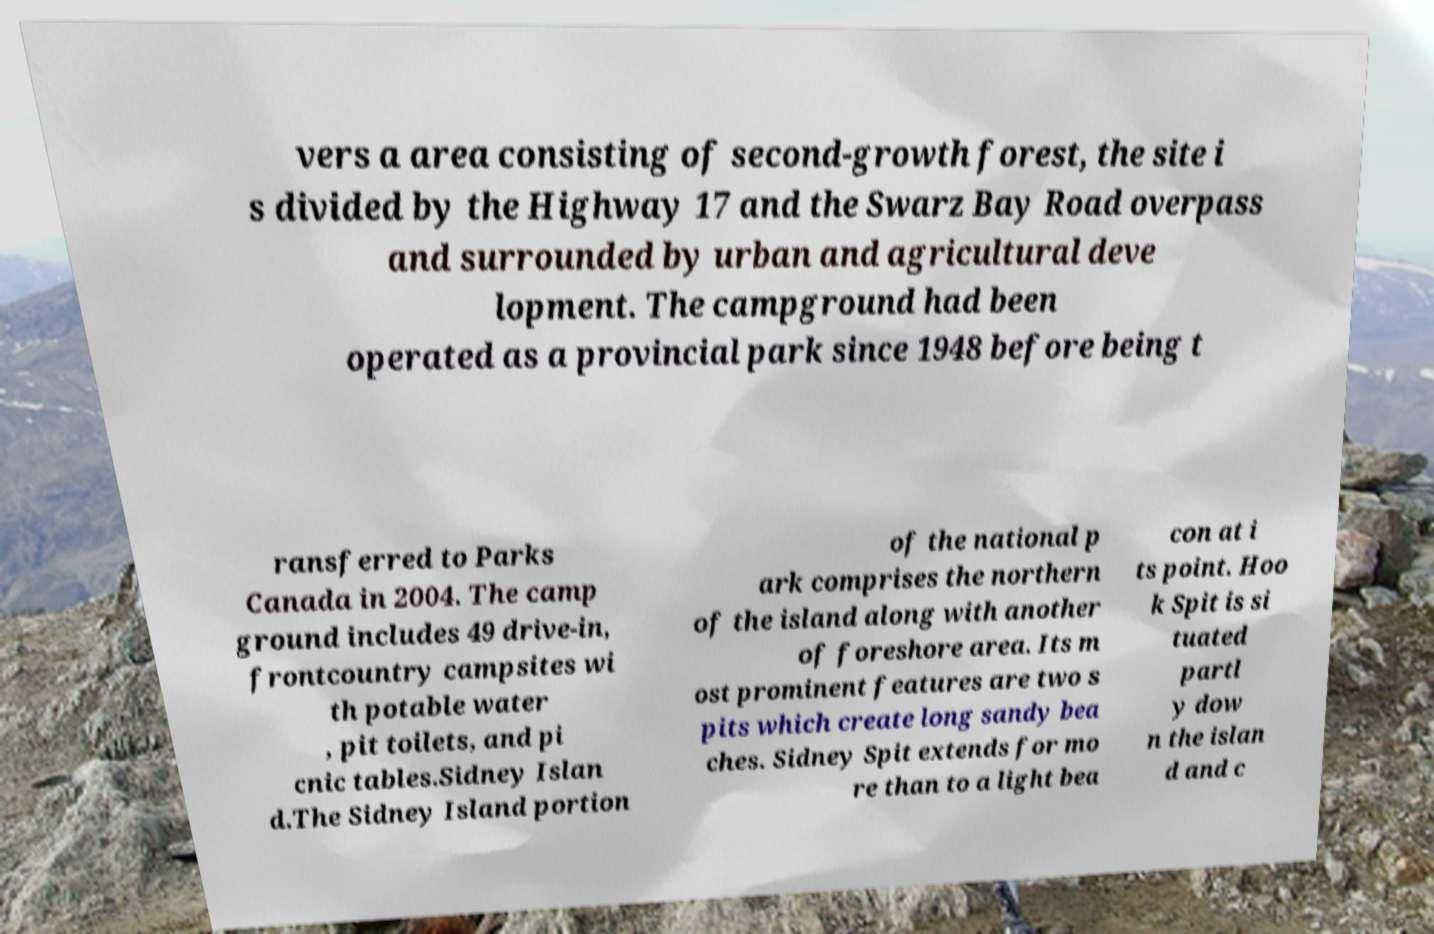What messages or text are displayed in this image? I need them in a readable, typed format. vers a area consisting of second-growth forest, the site i s divided by the Highway 17 and the Swarz Bay Road overpass and surrounded by urban and agricultural deve lopment. The campground had been operated as a provincial park since 1948 before being t ransferred to Parks Canada in 2004. The camp ground includes 49 drive-in, frontcountry campsites wi th potable water , pit toilets, and pi cnic tables.Sidney Islan d.The Sidney Island portion of the national p ark comprises the northern of the island along with another of foreshore area. Its m ost prominent features are two s pits which create long sandy bea ches. Sidney Spit extends for mo re than to a light bea con at i ts point. Hoo k Spit is si tuated partl y dow n the islan d and c 